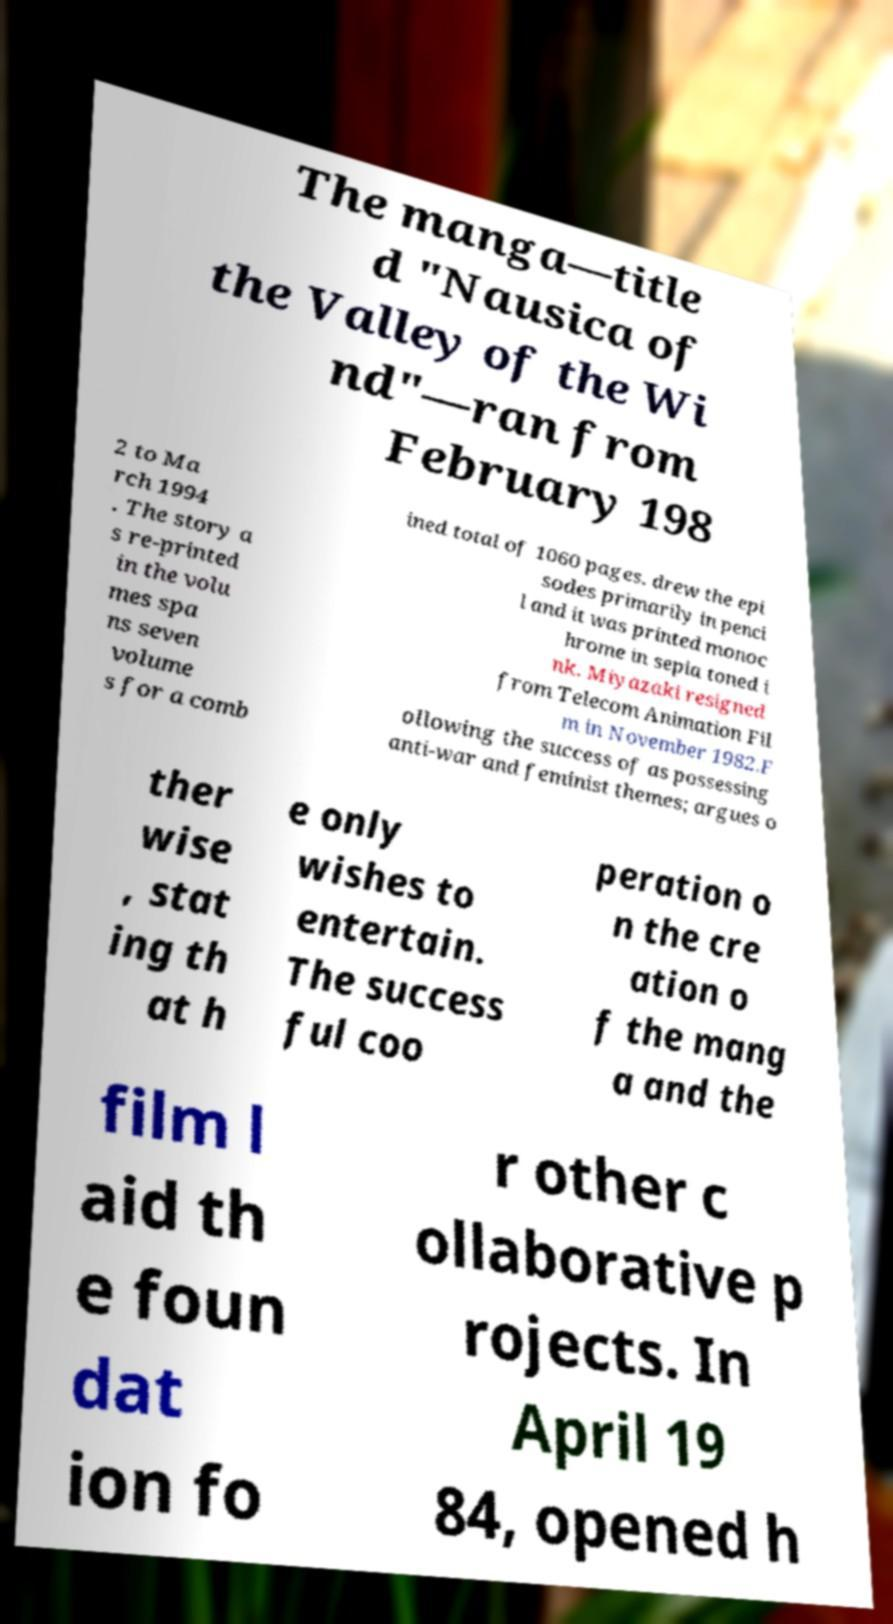There's text embedded in this image that I need extracted. Can you transcribe it verbatim? The manga—title d "Nausica of the Valley of the Wi nd"—ran from February 198 2 to Ma rch 1994 . The story a s re-printed in the volu mes spa ns seven volume s for a comb ined total of 1060 pages. drew the epi sodes primarily in penci l and it was printed monoc hrome in sepia toned i nk. Miyazaki resigned from Telecom Animation Fil m in November 1982.F ollowing the success of as possessing anti-war and feminist themes; argues o ther wise , stat ing th at h e only wishes to entertain. The success ful coo peration o n the cre ation o f the mang a and the film l aid th e foun dat ion fo r other c ollaborative p rojects. In April 19 84, opened h 